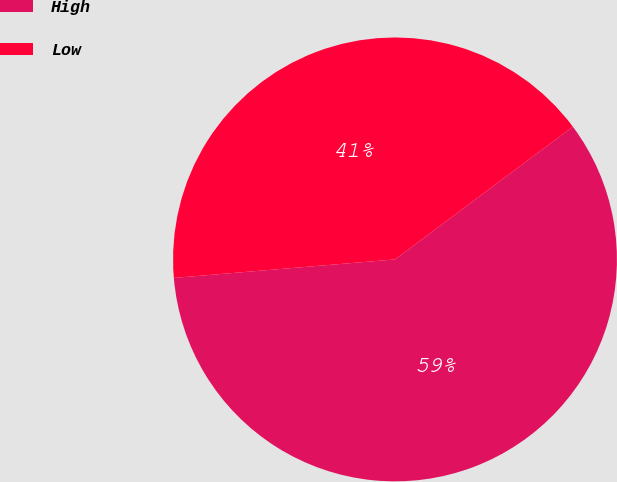Convert chart to OTSL. <chart><loc_0><loc_0><loc_500><loc_500><pie_chart><fcel>High<fcel>Low<nl><fcel>58.87%<fcel>41.13%<nl></chart> 